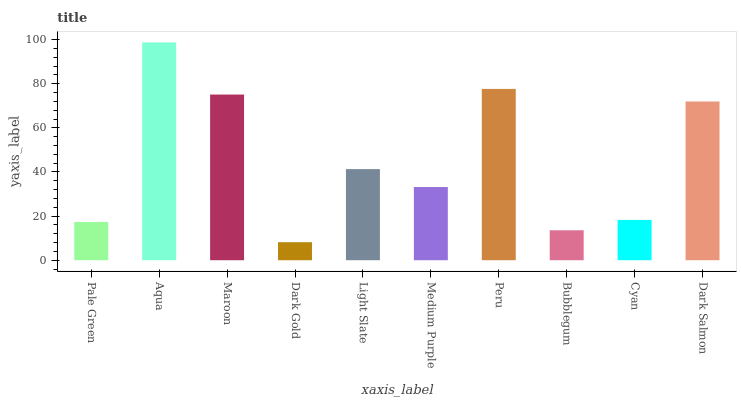Is Dark Gold the minimum?
Answer yes or no. Yes. Is Aqua the maximum?
Answer yes or no. Yes. Is Maroon the minimum?
Answer yes or no. No. Is Maroon the maximum?
Answer yes or no. No. Is Aqua greater than Maroon?
Answer yes or no. Yes. Is Maroon less than Aqua?
Answer yes or no. Yes. Is Maroon greater than Aqua?
Answer yes or no. No. Is Aqua less than Maroon?
Answer yes or no. No. Is Light Slate the high median?
Answer yes or no. Yes. Is Medium Purple the low median?
Answer yes or no. Yes. Is Pale Green the high median?
Answer yes or no. No. Is Peru the low median?
Answer yes or no. No. 